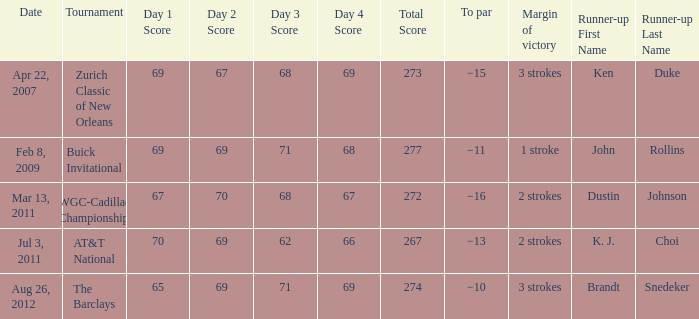What was the winning difference when brandt snedeker finished second? 3 strokes. 